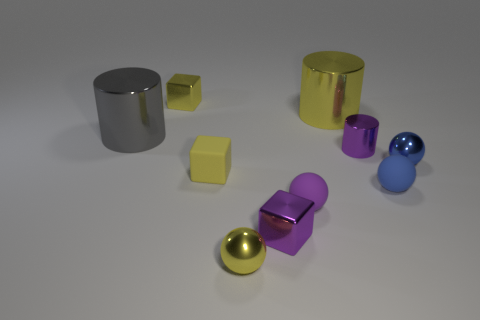There is a large thing that is on the right side of the yellow shiny object in front of the large metal object behind the gray metal object; what is it made of? The large object on the right side of the yellow shiny object, which appears in front of another metal object and behind the gray one, seems to be made of a reflective metal as well, possibly steel or aluminum, judging by the shiny surface and how it reflects the environment. 